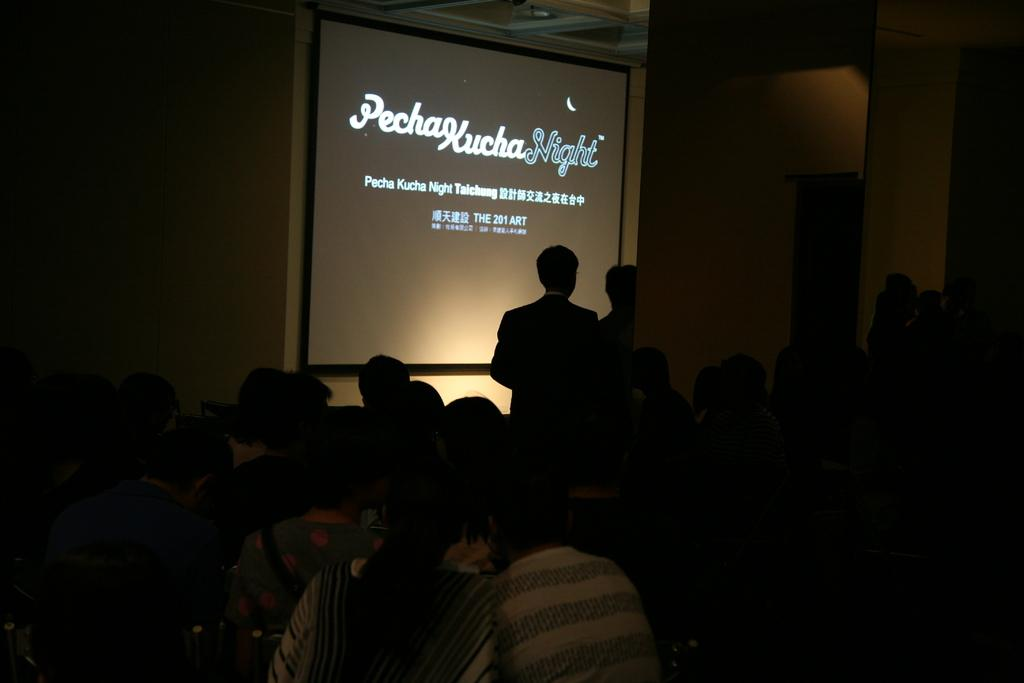How many people are in the image? There is a group of people in the image, but the exact number cannot be determined from the provided facts. What is happening in the image? The image shows a group of people and text projected on a wall. Can you describe the text on the wall? Unfortunately, the specific content of the text cannot be determined from the provided facts. What type of brake is being used by the van in the image? There is no van present in the image, so it is not possible to determine what type of brake might be used. 